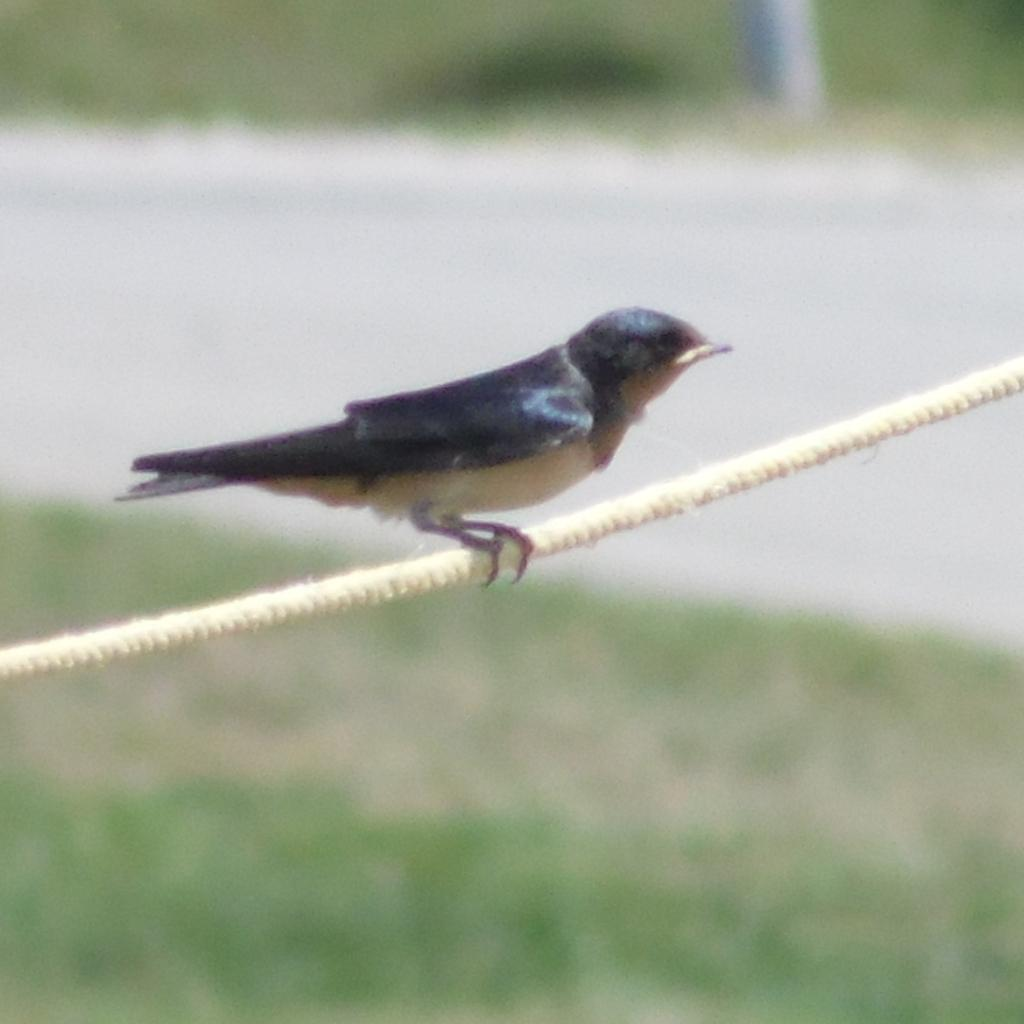What is the main subject in the center of the image? There is a bird in the center of the image. How is the bird positioned in the image? The bird is on a rope. What type of terrain is visible at the bottom of the image? There is grass and a walkway at the bottom of the image. What type of terrain is visible at the top of the image? There is grass at the top of the image. What type of song is the bird singing in the image? There is no indication in the image that the bird is singing, so it cannot be determined from the picture. 